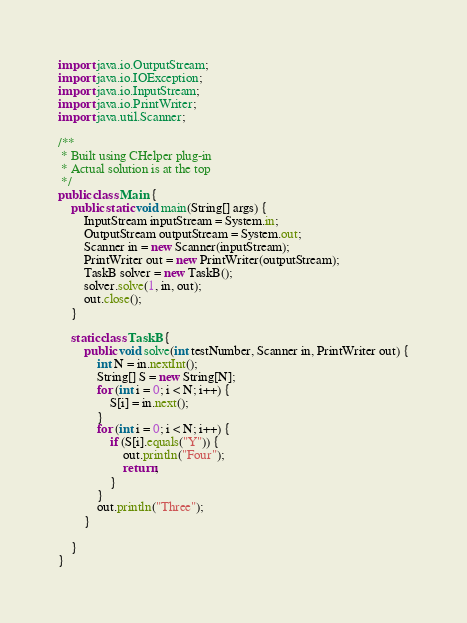Convert code to text. <code><loc_0><loc_0><loc_500><loc_500><_Java_>import java.io.OutputStream;
import java.io.IOException;
import java.io.InputStream;
import java.io.PrintWriter;
import java.util.Scanner;

/**
 * Built using CHelper plug-in
 * Actual solution is at the top
 */
public class Main {
    public static void main(String[] args) {
        InputStream inputStream = System.in;
        OutputStream outputStream = System.out;
        Scanner in = new Scanner(inputStream);
        PrintWriter out = new PrintWriter(outputStream);
        TaskB solver = new TaskB();
        solver.solve(1, in, out);
        out.close();
    }

    static class TaskB {
        public void solve(int testNumber, Scanner in, PrintWriter out) {
            int N = in.nextInt();
            String[] S = new String[N];
            for (int i = 0; i < N; i++) {
                S[i] = in.next();
            }
            for (int i = 0; i < N; i++) {
                if (S[i].equals("Y")) {
                    out.println("Four");
                    return;
                }
            }
            out.println("Three");
        }

    }
}

</code> 